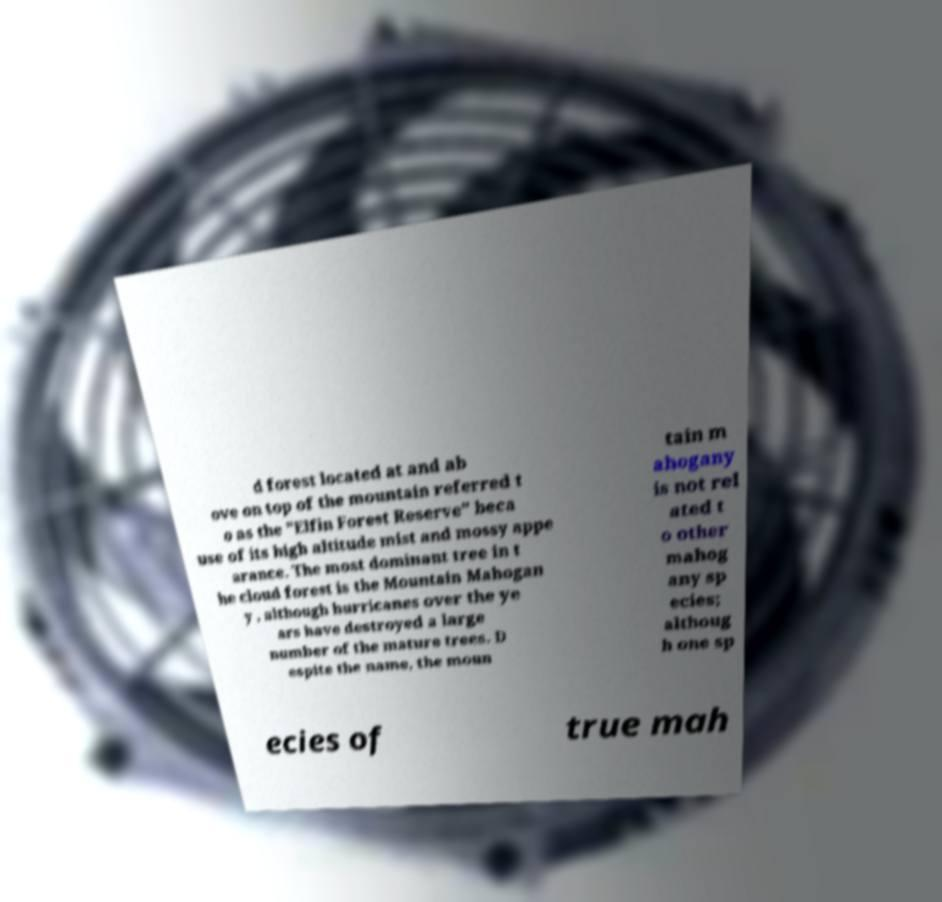Can you accurately transcribe the text from the provided image for me? d forest located at and ab ove on top of the mountain referred t o as the "Elfin Forest Reserve" beca use of its high altitude mist and mossy appe arance. The most dominant tree in t he cloud forest is the Mountain Mahogan y , although hurricanes over the ye ars have destroyed a large number of the mature trees. D espite the name, the moun tain m ahogany is not rel ated t o other mahog any sp ecies; althoug h one sp ecies of true mah 